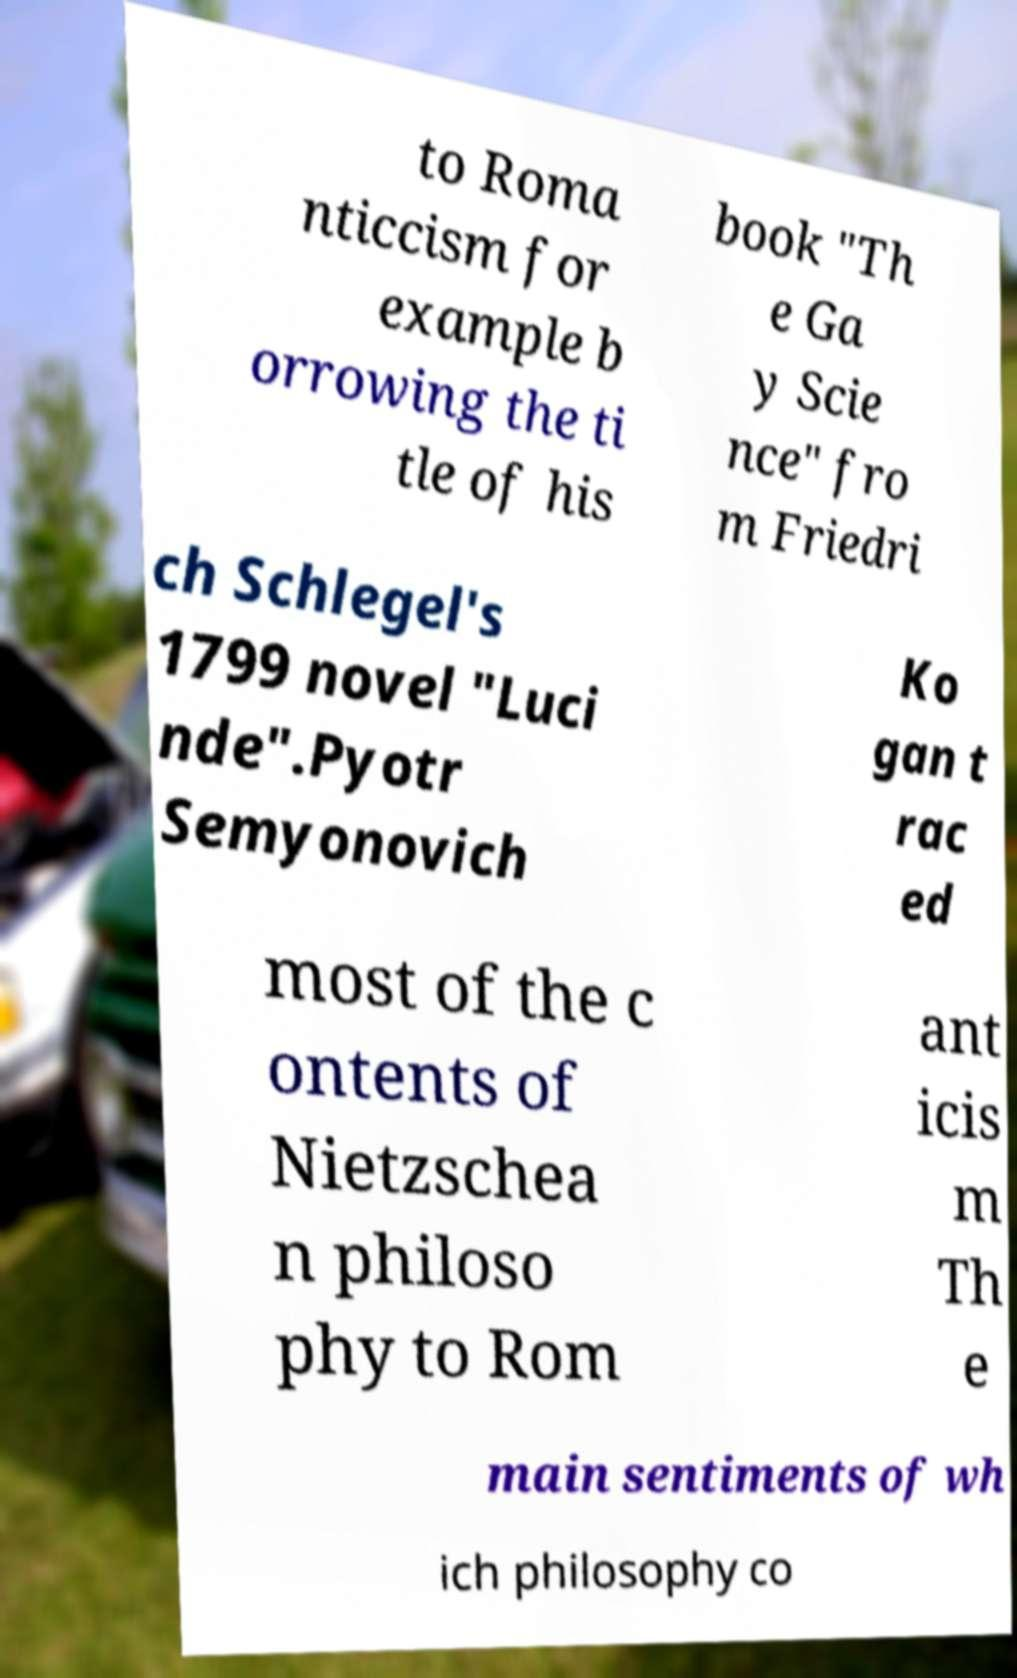What messages or text are displayed in this image? I need them in a readable, typed format. to Roma nticcism for example b orrowing the ti tle of his book "Th e Ga y Scie nce" fro m Friedri ch Schlegel's 1799 novel "Luci nde".Pyotr Semyonovich Ko gan t rac ed most of the c ontents of Nietzschea n philoso phy to Rom ant icis m Th e main sentiments of wh ich philosophy co 